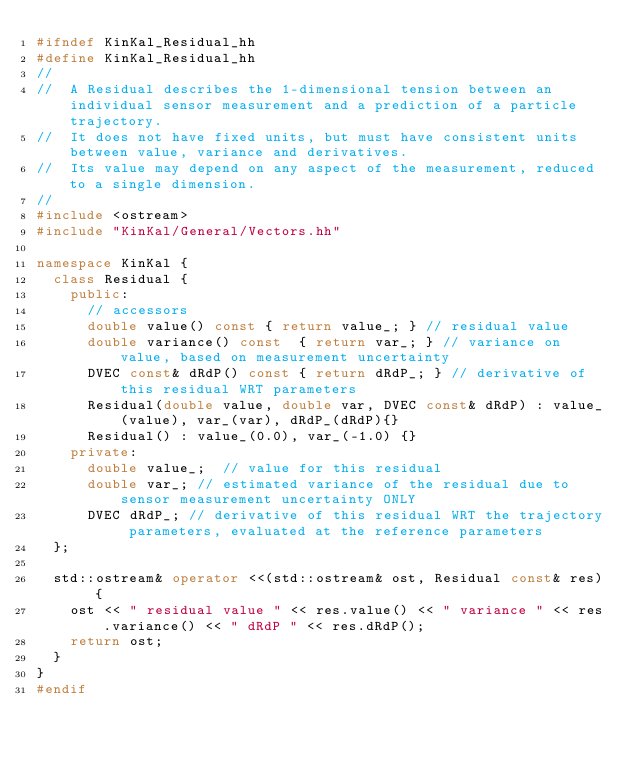Convert code to text. <code><loc_0><loc_0><loc_500><loc_500><_C++_>#ifndef KinKal_Residual_hh
#define KinKal_Residual_hh
//
//  A Residual describes the 1-dimensional tension between an individual sensor measurement and a prediction of a particle trajectory.
//  It does not have fixed units, but must have consistent units between value, variance and derivatives.
//  Its value may depend on any aspect of the measurement, reduced to a single dimension.
//
#include <ostream>
#include "KinKal/General/Vectors.hh"

namespace KinKal {
  class Residual {
    public:
      // accessors
      double value() const { return value_; } // residual value
      double variance() const  { return var_; } // variance on value, based on measurement uncertainty
      DVEC const& dRdP() const { return dRdP_; } // derivative of this residual WRT parameters 
      Residual(double value, double var, DVEC const& dRdP) : value_(value), var_(var), dRdP_(dRdP){}
      Residual() : value_(0.0), var_(-1.0) {}
    private:
      double value_;  // value for this residual
      double var_; // estimated variance of the residual due to sensor measurement uncertainty ONLY
      DVEC dRdP_; // derivative of this residual WRT the trajectory parameters, evaluated at the reference parameters
  };

  std::ostream& operator <<(std::ostream& ost, Residual const& res) {
    ost << " residual value " << res.value() << " variance " << res.variance() << " dRdP " << res.dRdP();
    return ost;
  }
}
#endif
</code> 